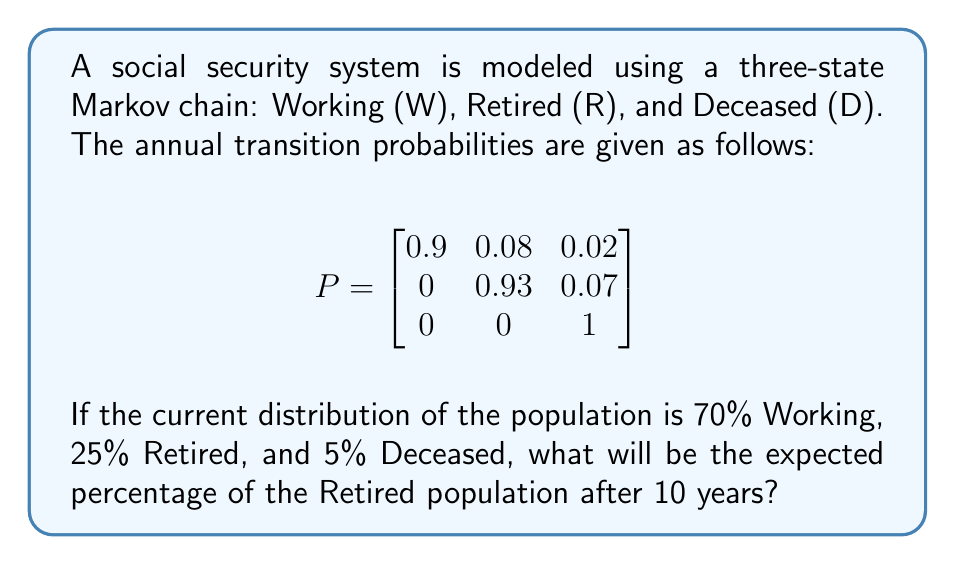Show me your answer to this math problem. To solve this problem, we need to follow these steps:

1) First, let's define our initial state vector:
   $$\pi_0 = [0.70, 0.25, 0.05]$$

2) We need to calculate $\pi_{10} = \pi_0 P^{10}$

3) To calculate $P^{10}$, we can use diagonalization or matrix multiplication. For simplicity, let's use matrix multiplication:

   $$P^2 = \begin{bmatrix}
   0.8170 & 0.1486 & 0.0344 \\
   0 & 0.8649 & 0.1351 \\
   0 & 0 & 1
   \end{bmatrix}$$

   $$P^4 = \begin{bmatrix}
   0.6676 & 0.2571 & 0.0753 \\
   0 & 0.7478 & 0.2522 \\
   0 & 0 & 1
   \end{bmatrix}$$

   $$P^8 = \begin{bmatrix}
   0.4457 & 0.3968 & 0.1575 \\
   0 & 0.5592 & 0.4408 \\
   0 & 0 & 1
   \end{bmatrix}$$

   $$P^{10} = \begin{bmatrix}
   0.3611 & 0.4358 & 0.2031 \\
   0 & 0.4835 & 0.5165 \\
   0 & 0 & 1
   \end{bmatrix}$$

4) Now we can calculate $\pi_{10}$:

   $$\pi_{10} = [0.70, 0.25, 0.05] \begin{bmatrix}
   0.3611 & 0.4358 & 0.2031 \\
   0 & 0.4835 & 0.5165 \\
   0 & 0 & 1
   \end{bmatrix}$$

   $$\pi_{10} = [0.2528, 0.4257, 0.3215]$$

5) The percentage of the Retired population after 10 years is the second element of $\pi_{10}$, which is 0.4257 or 42.57%.
Answer: 42.57% 